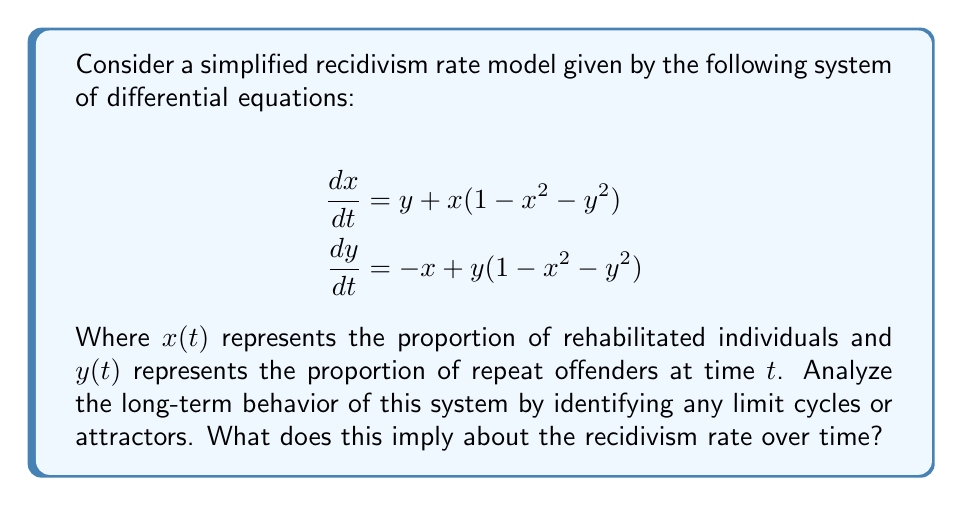Teach me how to tackle this problem. To analyze the long-term behavior of this system, we'll follow these steps:

1) First, let's convert the system to polar coordinates:
   Let $r^2 = x^2 + y^2$, then:
   
   $$\begin{align}
   \frac{dr}{dt} &= r(1-r^2) \\
   \frac{d\theta}{dt} &= -1
   \end{align}$$

2) Examine the radial equation $\frac{dr}{dt} = r(1-r^2)$:
   - When $r = 0$, $\frac{dr}{dt} = 0$ (stable equilibrium at origin)
   - When $r = 1$, $\frac{dr}{dt} = 0$ (potential limit cycle)
   - When $0 < r < 1$, $\frac{dr}{dt} > 0$ (r increases)
   - When $r > 1$, $\frac{dr}{dt} < 0$ (r decreases)

3) The angular equation $\frac{d\theta}{dt} = -1$ indicates constant rotation.

4) From this analysis, we can conclude:
   - There's a stable limit cycle when $r = 1$
   - The origin $(0,0)$ is an unstable equilibrium point
   - All trajectories (except the origin) will approach the limit cycle as $t \to \infty$

5) In the context of recidivism:
   - The limit cycle represents a periodic fluctuation between rehabilitation and reoffending
   - The system will always tend towards this cycle, regardless of initial conditions
   - This suggests that, in this model, the recidivism rate will oscillate around a fixed value over time

[asy]
import graph;
size(200);
real f(real x) {return sqrt(1-x^2);}
draw(circle((0,0),1),blue);
draw((-1.2,0)--(1.2,0),Arrow);
draw((0,-1.2)--(0,1.2),Arrow);
draw((0.2,0.2)..(0.7,0.7)..(1,0),red,Arrow);
draw((-0.2,-0.2)..(-0.7,-0.7)..(-1,0),red,Arrow);
label("x",(1.2,0),E);
label("y",(0,1.2),N);
label("Limit cycle",(-0.5,1),NW);
[/asy]
Answer: The system exhibits a stable limit cycle at $r=1$, indicating periodic oscillation between rehabilitation and reoffending. 